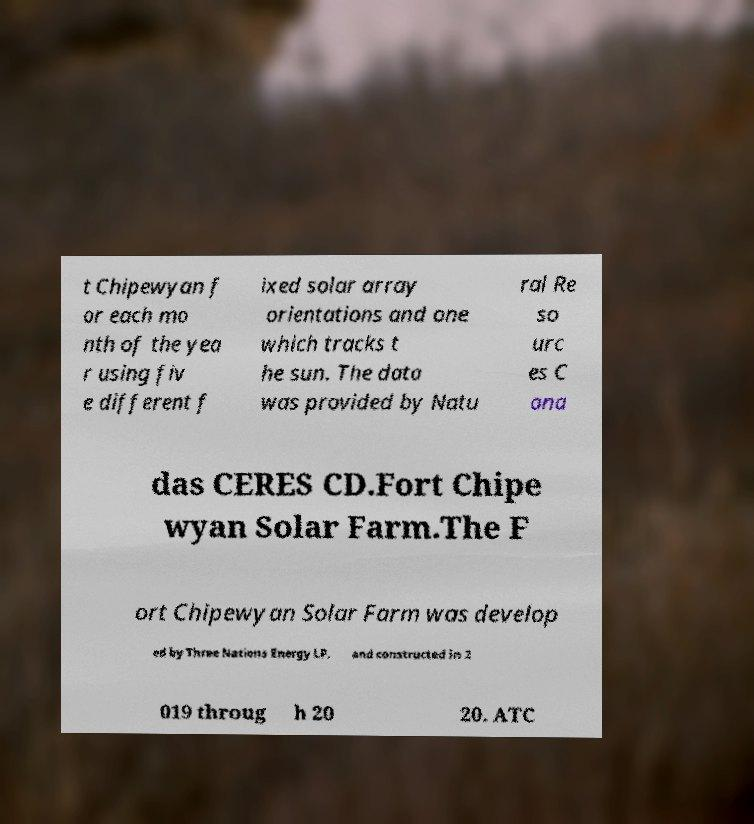There's text embedded in this image that I need extracted. Can you transcribe it verbatim? t Chipewyan f or each mo nth of the yea r using fiv e different f ixed solar array orientations and one which tracks t he sun. The data was provided by Natu ral Re so urc es C ana das CERES CD.Fort Chipe wyan Solar Farm.The F ort Chipewyan Solar Farm was develop ed by Three Nations Energy LP, and constructed in 2 019 throug h 20 20. ATC 